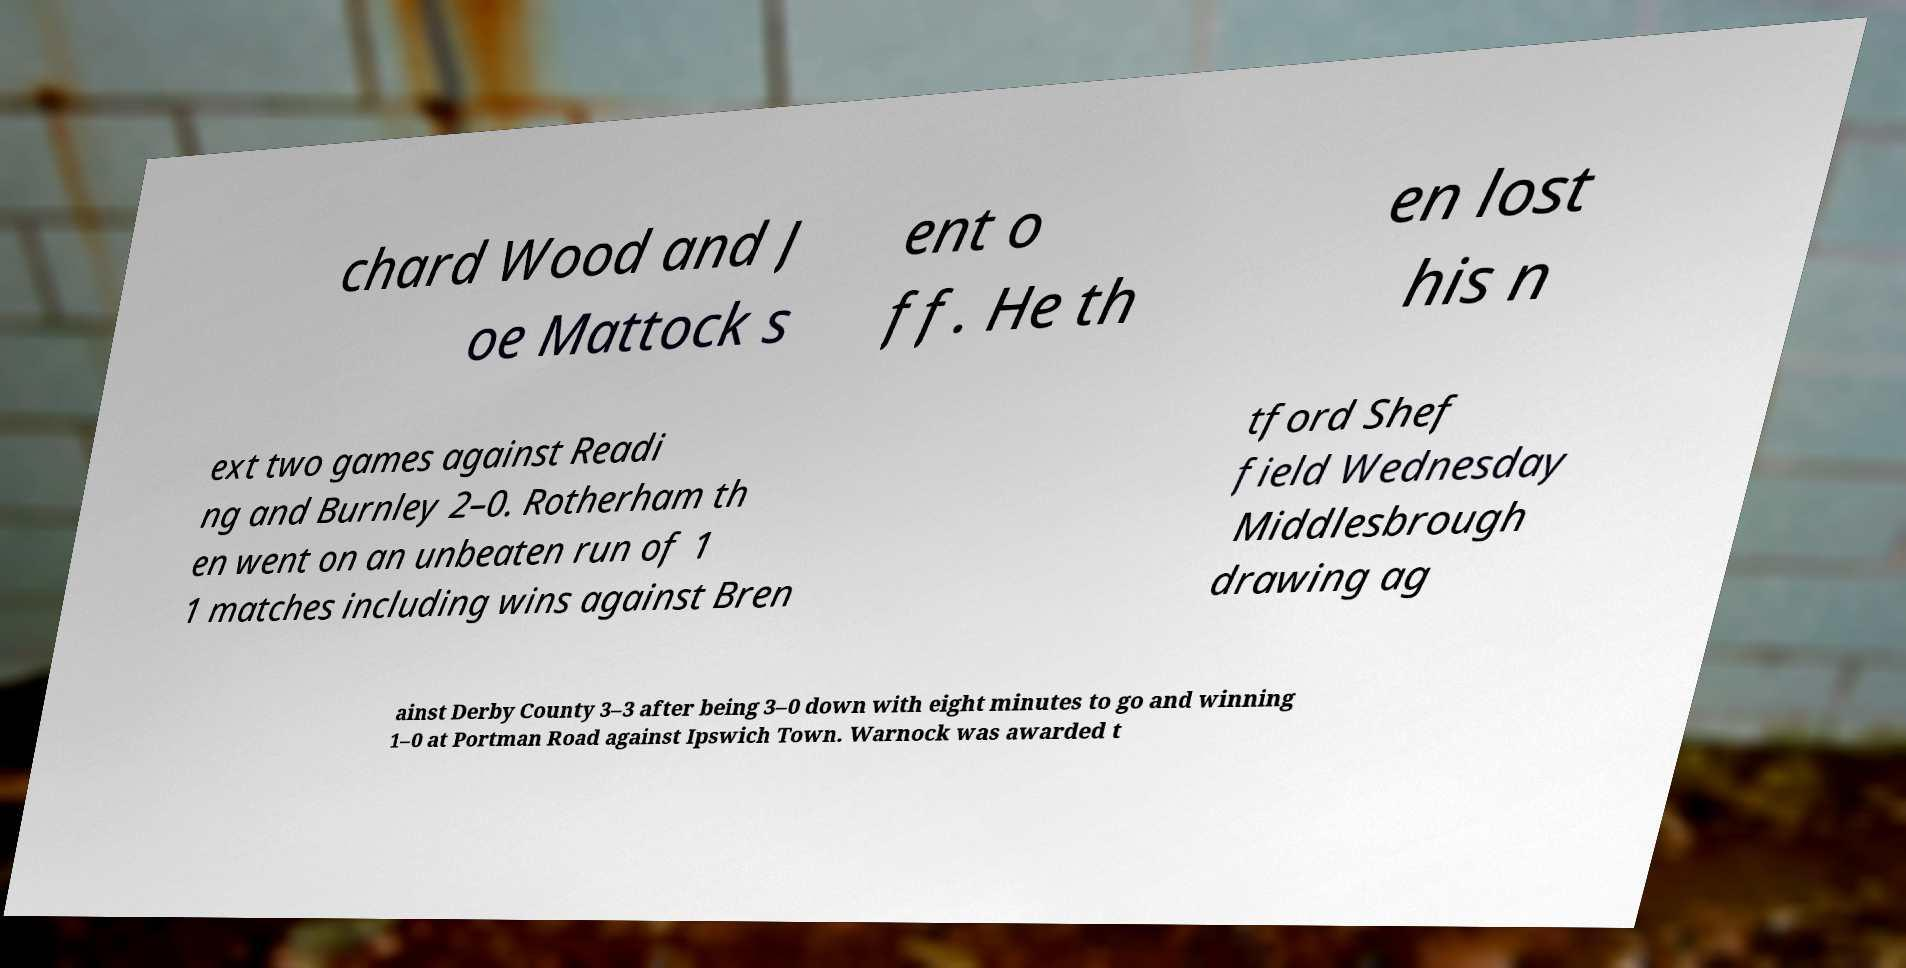Could you assist in decoding the text presented in this image and type it out clearly? chard Wood and J oe Mattock s ent o ff. He th en lost his n ext two games against Readi ng and Burnley 2–0. Rotherham th en went on an unbeaten run of 1 1 matches including wins against Bren tford Shef field Wednesday Middlesbrough drawing ag ainst Derby County 3–3 after being 3–0 down with eight minutes to go and winning 1–0 at Portman Road against Ipswich Town. Warnock was awarded t 